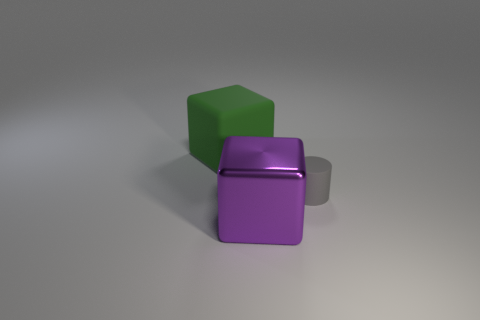Add 3 big yellow objects. How many objects exist? 6 Subtract all blocks. How many objects are left? 1 Add 2 small gray rubber cylinders. How many small gray rubber cylinders exist? 3 Subtract 0 yellow cylinders. How many objects are left? 3 Subtract all green rubber objects. Subtract all gray rubber cylinders. How many objects are left? 1 Add 2 gray matte cylinders. How many gray matte cylinders are left? 3 